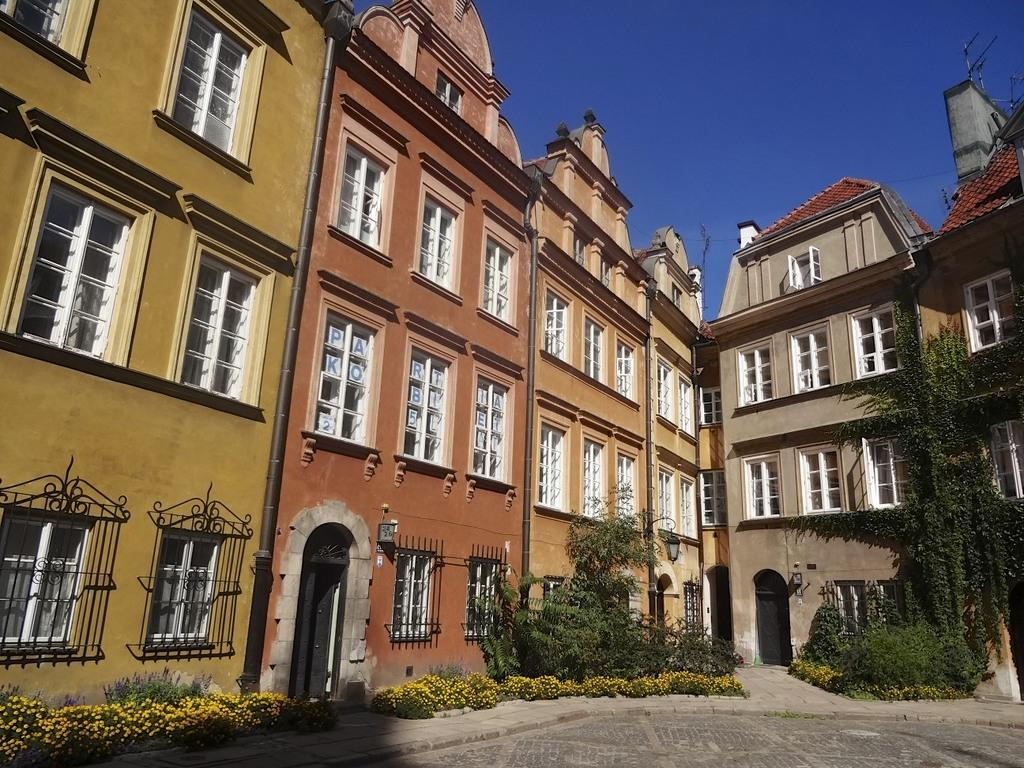What type of structures can be seen in the image? There are buildings in the image. What type of vegetation is present in the image? There are trees and flower plants in the image. What else can be found on the ground in the image? There are other objects on the ground in the image. What is visible in the background of the image? The sky is visible in the background of the image. What type of vessel is being used for medical treatment in the image? There is no vessel or medical treatment present in the image. Where is the drawer located in the image? There is no drawer present in the image. 